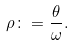<formula> <loc_0><loc_0><loc_500><loc_500>\rho \colon = \frac { \theta } { \omega } .</formula> 